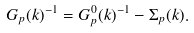<formula> <loc_0><loc_0><loc_500><loc_500>G _ { p } ( k ) ^ { - 1 } = G ^ { 0 } _ { p } ( k ) ^ { - 1 } - \Sigma _ { p } ( k ) .</formula> 